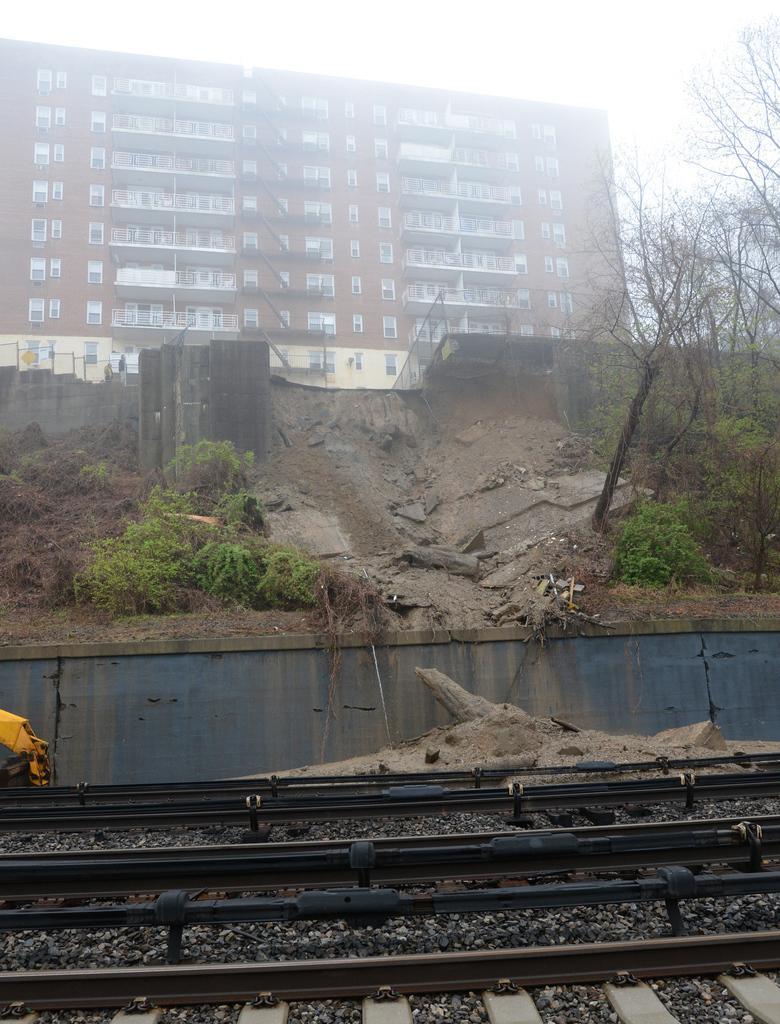Could you give a brief overview of what you see in this image? In the image we can see there are railway tracks on the ground and there are plants and trees. Behind there is a building and there is a clear sky. 